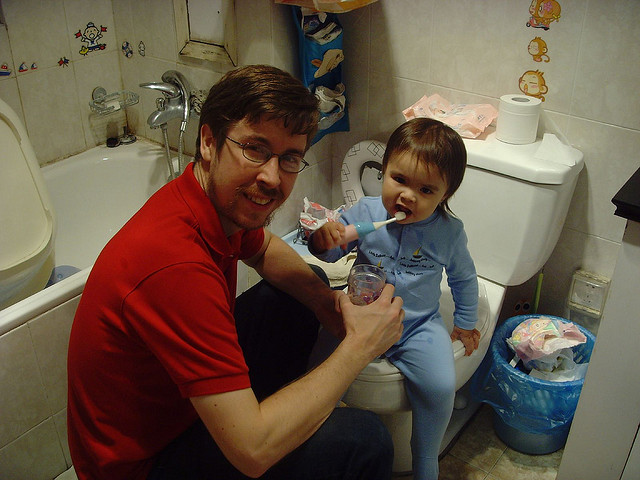<image>What animal is seen here? There is no animal seen in the image. It could be a human. What animal is seen here? I don't know what animal is seen here. It can be both monkey and human. 